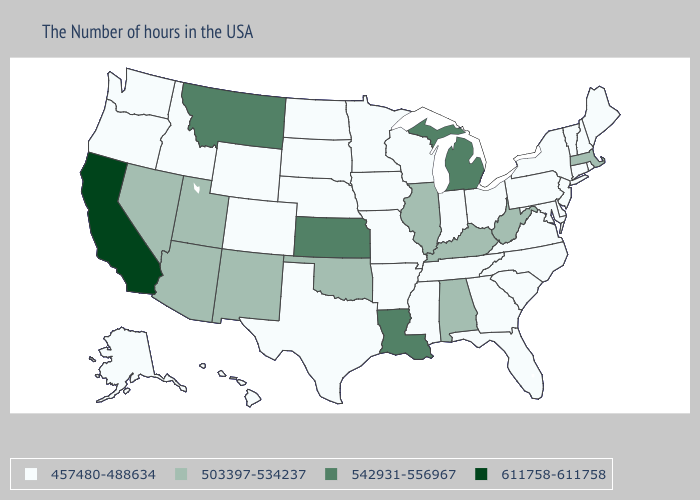Is the legend a continuous bar?
Answer briefly. No. Does the first symbol in the legend represent the smallest category?
Give a very brief answer. Yes. Does Georgia have a lower value than North Dakota?
Answer briefly. No. What is the value of North Carolina?
Be succinct. 457480-488634. What is the value of Kentucky?
Give a very brief answer. 503397-534237. Which states hav the highest value in the West?
Answer briefly. California. What is the highest value in states that border Ohio?
Be succinct. 542931-556967. Name the states that have a value in the range 503397-534237?
Answer briefly. Massachusetts, West Virginia, Kentucky, Alabama, Illinois, Oklahoma, New Mexico, Utah, Arizona, Nevada. What is the lowest value in the USA?
Write a very short answer. 457480-488634. Does Montana have the lowest value in the West?
Concise answer only. No. How many symbols are there in the legend?
Be succinct. 4. What is the value of New Jersey?
Answer briefly. 457480-488634. Which states have the lowest value in the MidWest?
Be succinct. Ohio, Indiana, Wisconsin, Missouri, Minnesota, Iowa, Nebraska, South Dakota, North Dakota. 